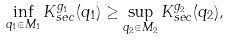<formula> <loc_0><loc_0><loc_500><loc_500>\inf _ { q _ { 1 } \in M _ { 1 } } K _ { s e c } ^ { g _ { 1 } } ( q _ { 1 } ) \geq \sup _ { q _ { 2 } \in M _ { 2 } } K _ { s e c } ^ { g _ { 2 } } ( q _ { 2 } ) ,</formula> 